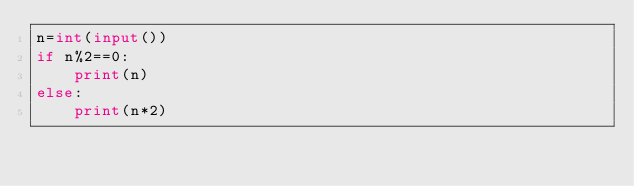<code> <loc_0><loc_0><loc_500><loc_500><_Python_>n=int(input())
if n%2==0:
    print(n)
else:
    print(n*2)
</code> 